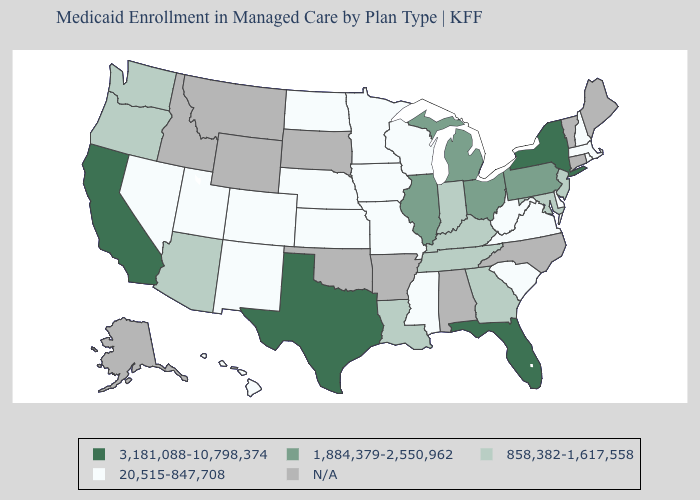Does the first symbol in the legend represent the smallest category?
Be succinct. No. Name the states that have a value in the range 858,382-1,617,558?
Concise answer only. Arizona, Georgia, Indiana, Kentucky, Louisiana, Maryland, New Jersey, Oregon, Tennessee, Washington. Which states have the lowest value in the USA?
Keep it brief. Colorado, Delaware, Hawaii, Iowa, Kansas, Massachusetts, Minnesota, Mississippi, Missouri, Nebraska, Nevada, New Hampshire, New Mexico, North Dakota, Rhode Island, South Carolina, Utah, Virginia, West Virginia, Wisconsin. Does the map have missing data?
Write a very short answer. Yes. Name the states that have a value in the range 1,884,379-2,550,962?
Write a very short answer. Illinois, Michigan, Ohio, Pennsylvania. What is the highest value in the USA?
Be succinct. 3,181,088-10,798,374. What is the value of Vermont?
Short answer required. N/A. Is the legend a continuous bar?
Concise answer only. No. Which states have the lowest value in the USA?
Give a very brief answer. Colorado, Delaware, Hawaii, Iowa, Kansas, Massachusetts, Minnesota, Mississippi, Missouri, Nebraska, Nevada, New Hampshire, New Mexico, North Dakota, Rhode Island, South Carolina, Utah, Virginia, West Virginia, Wisconsin. Name the states that have a value in the range 20,515-847,708?
Short answer required. Colorado, Delaware, Hawaii, Iowa, Kansas, Massachusetts, Minnesota, Mississippi, Missouri, Nebraska, Nevada, New Hampshire, New Mexico, North Dakota, Rhode Island, South Carolina, Utah, Virginia, West Virginia, Wisconsin. Name the states that have a value in the range 858,382-1,617,558?
Answer briefly. Arizona, Georgia, Indiana, Kentucky, Louisiana, Maryland, New Jersey, Oregon, Tennessee, Washington. What is the highest value in the South ?
Keep it brief. 3,181,088-10,798,374. Does the first symbol in the legend represent the smallest category?
Quick response, please. No. 